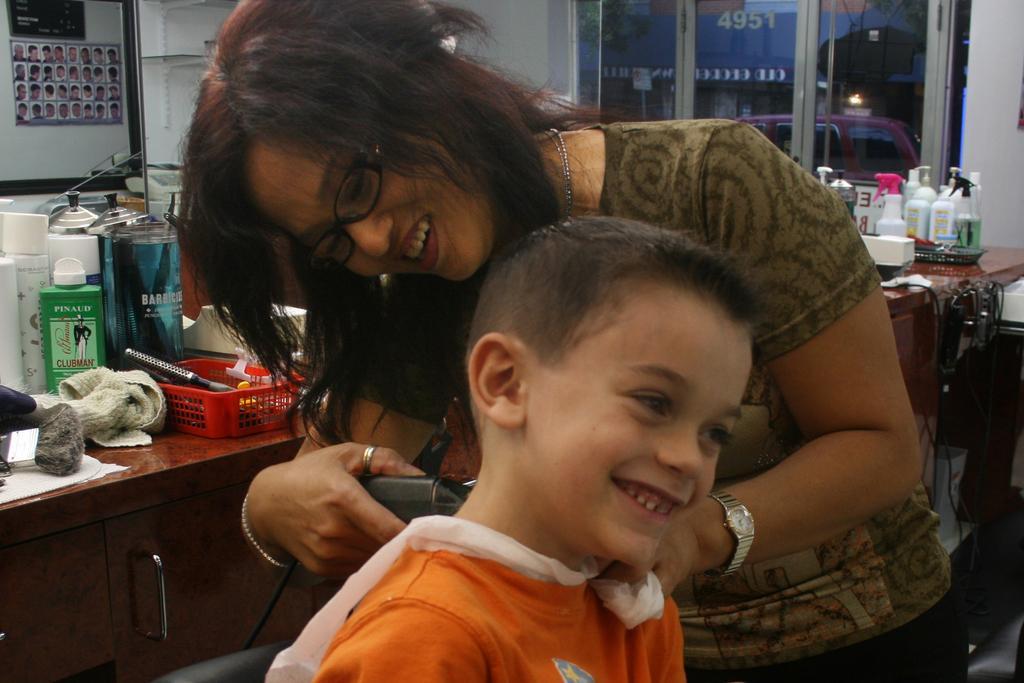Can you describe this image briefly? The girl in the middle of the picture who is standing is cutting the hair of a boy who is wearing an orange T-shirt. Both of them are smiling. Behind them, we see a table on which basket containing comb, lotion bottles and napkins are placed. Behind that, we see a mirror. On the right side, we see a table on which many white plastic bottles are placed. Behind that, we see a white wall and a window. 